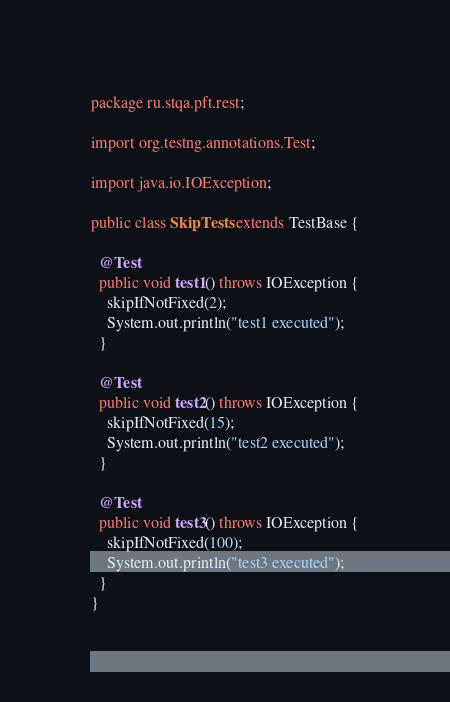<code> <loc_0><loc_0><loc_500><loc_500><_Java_>package ru.stqa.pft.rest;

import org.testng.annotations.Test;

import java.io.IOException;

public class SkipTests extends TestBase {

  @Test
  public void test1() throws IOException {
    skipIfNotFixed(2);
    System.out.println("test1 executed");
  }

  @Test
  public void test2() throws IOException {
    skipIfNotFixed(15);
    System.out.println("test2 executed");
  }

  @Test
  public void test3() throws IOException {
    skipIfNotFixed(100);
    System.out.println("test3 executed");
  }
}
</code> 